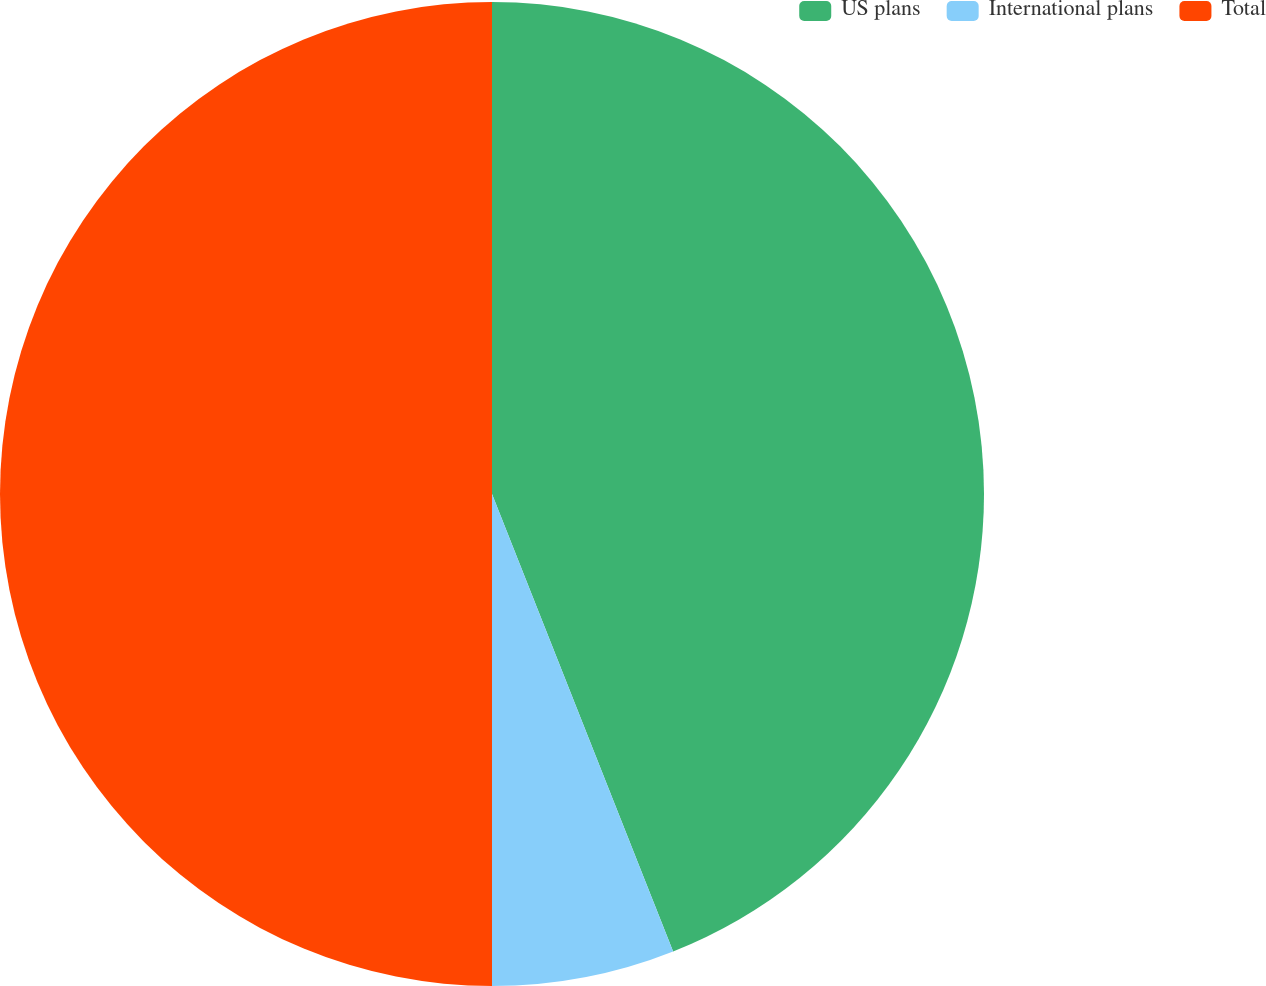<chart> <loc_0><loc_0><loc_500><loc_500><pie_chart><fcel>US plans<fcel>International plans<fcel>Total<nl><fcel>44.0%<fcel>6.0%<fcel>50.0%<nl></chart> 